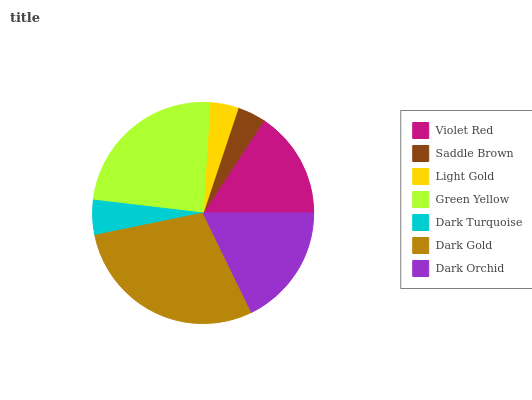Is Saddle Brown the minimum?
Answer yes or no. Yes. Is Dark Gold the maximum?
Answer yes or no. Yes. Is Light Gold the minimum?
Answer yes or no. No. Is Light Gold the maximum?
Answer yes or no. No. Is Light Gold greater than Saddle Brown?
Answer yes or no. Yes. Is Saddle Brown less than Light Gold?
Answer yes or no. Yes. Is Saddle Brown greater than Light Gold?
Answer yes or no. No. Is Light Gold less than Saddle Brown?
Answer yes or no. No. Is Violet Red the high median?
Answer yes or no. Yes. Is Violet Red the low median?
Answer yes or no. Yes. Is Light Gold the high median?
Answer yes or no. No. Is Dark Turquoise the low median?
Answer yes or no. No. 